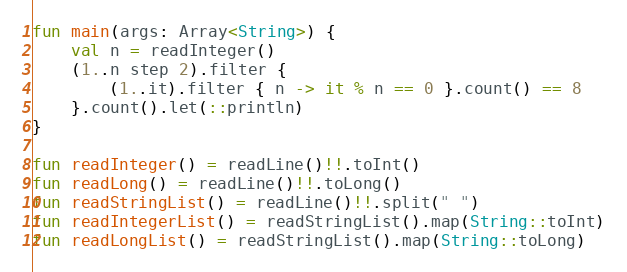<code> <loc_0><loc_0><loc_500><loc_500><_Kotlin_>fun main(args: Array<String>) {
    val n = readInteger()
    (1..n step 2).filter {
        (1..it).filter { n -> it % n == 0 }.count() == 8
    }.count().let(::println)
}

fun readInteger() = readLine()!!.toInt()
fun readLong() = readLine()!!.toLong()
fun readStringList() = readLine()!!.split(" ")
fun readIntegerList() = readStringList().map(String::toInt)
fun readLongList() = readStringList().map(String::toLong)
</code> 